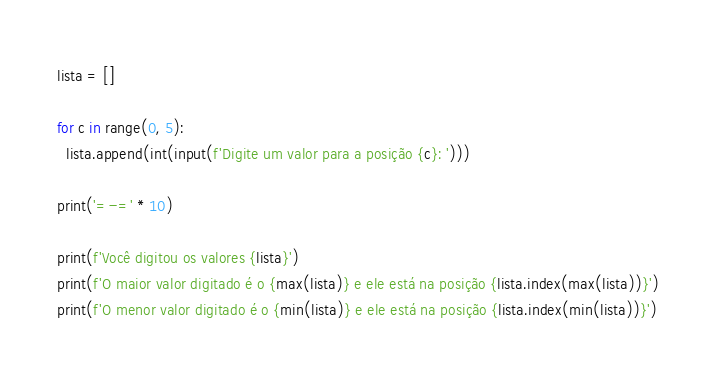Convert code to text. <code><loc_0><loc_0><loc_500><loc_500><_Python_>lista = []

for c in range(0, 5):
  lista.append(int(input(f'Digite um valor para a posição {c}: ')))

print('=-=' * 10)

print(f'Você digitou os valores {lista}')
print(f'O maior valor digitado é o {max(lista)} e ele está na posição {lista.index(max(lista))}')
print(f'O menor valor digitado é o {min(lista)} e ele está na posição {lista.index(min(lista))}')</code> 